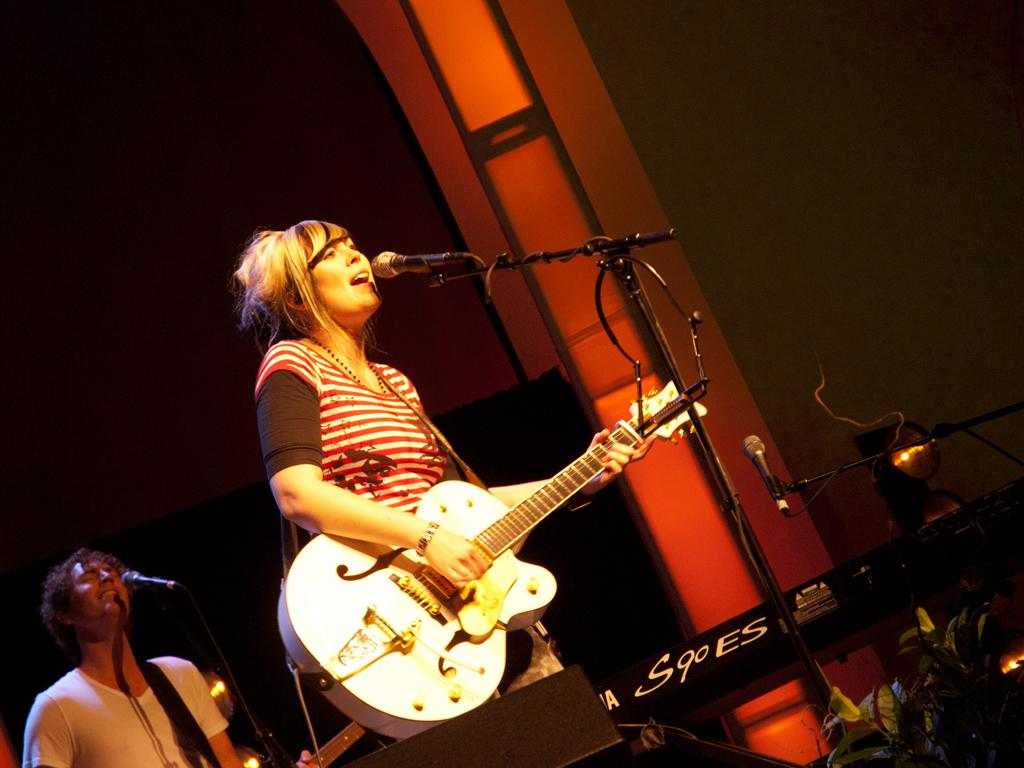What is the person in the foreground of the image doing? The person is standing in front of a mic and holding a guitar. Can you describe the person in the background of the image? There is another person standing in front of a mic in the background. What type of statement is the sheet of paper on the floor making in the image? There is no sheet of paper on the floor in the image. 